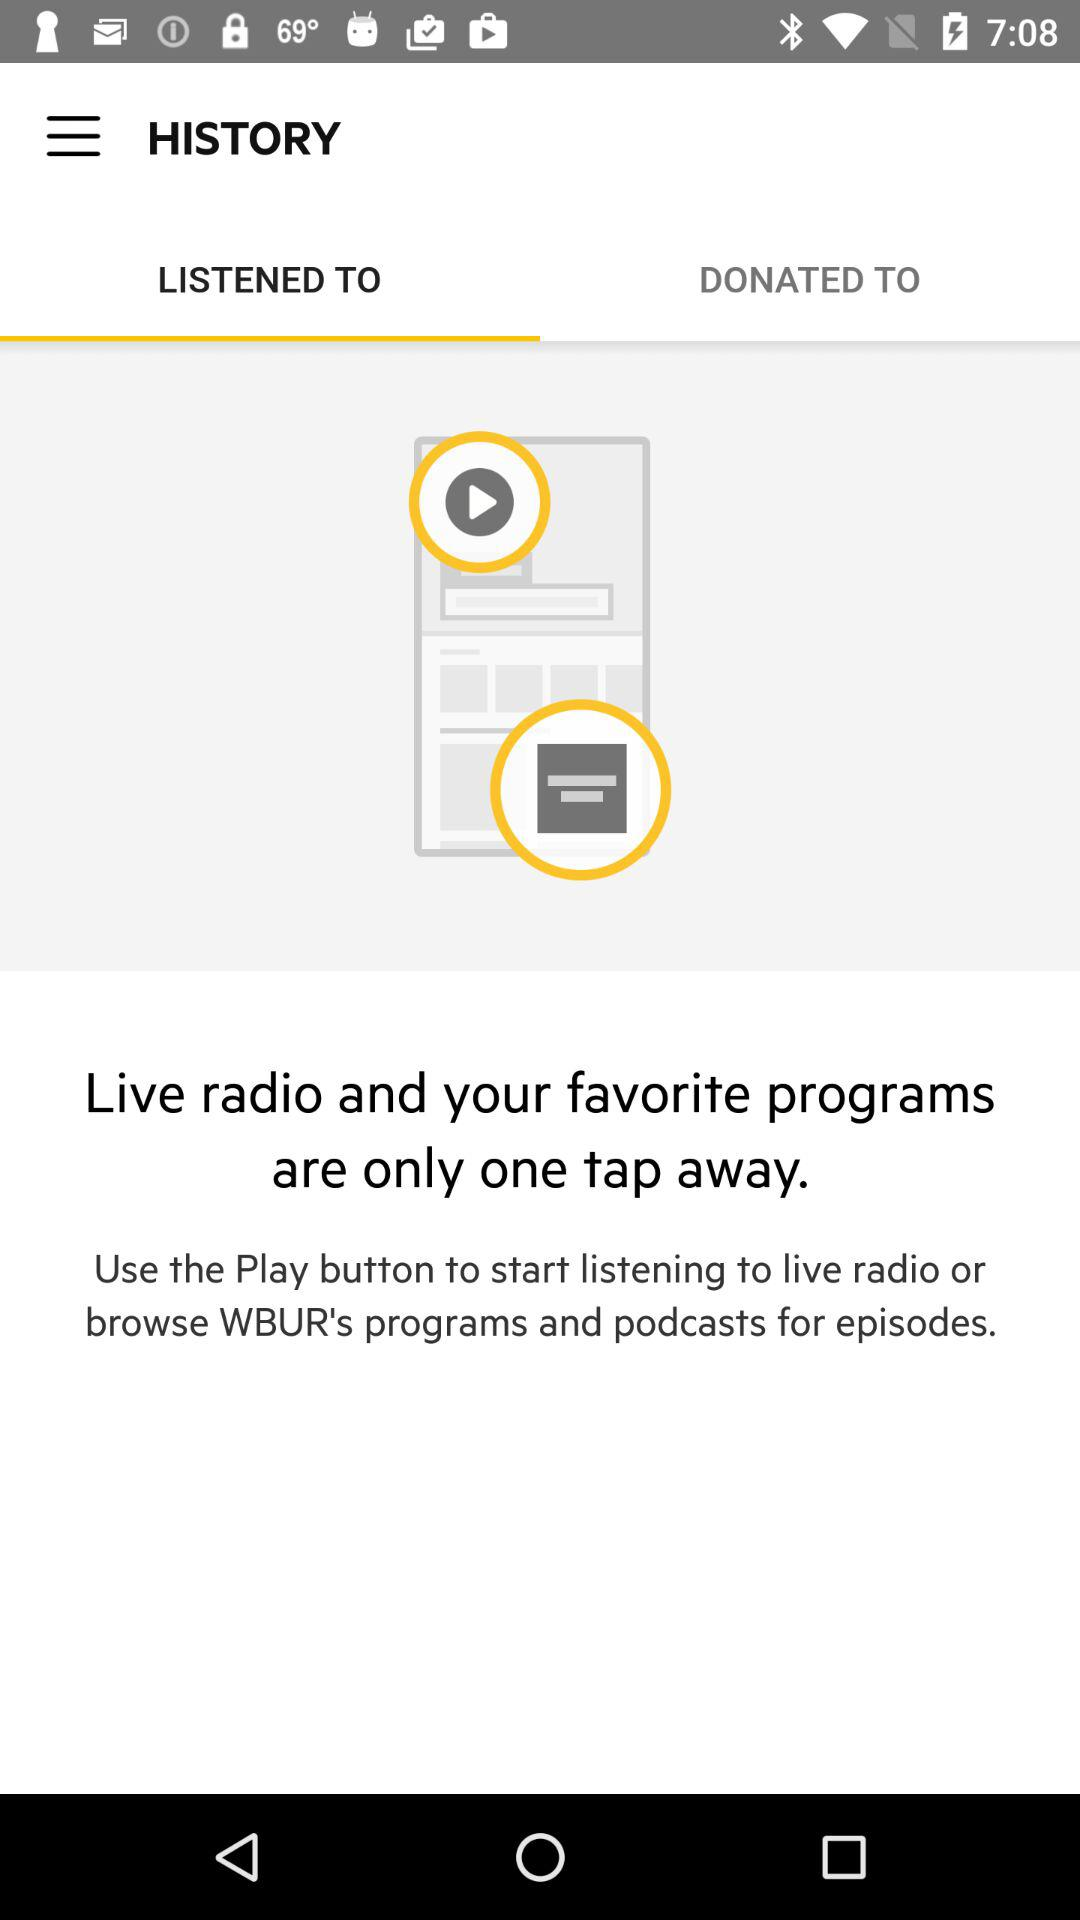Which tab am I using? You are using "LISTENED TO". 